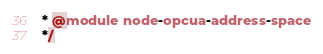<code> <loc_0><loc_0><loc_500><loc_500><_JavaScript_> * @module node-opcua-address-space
 */</code> 